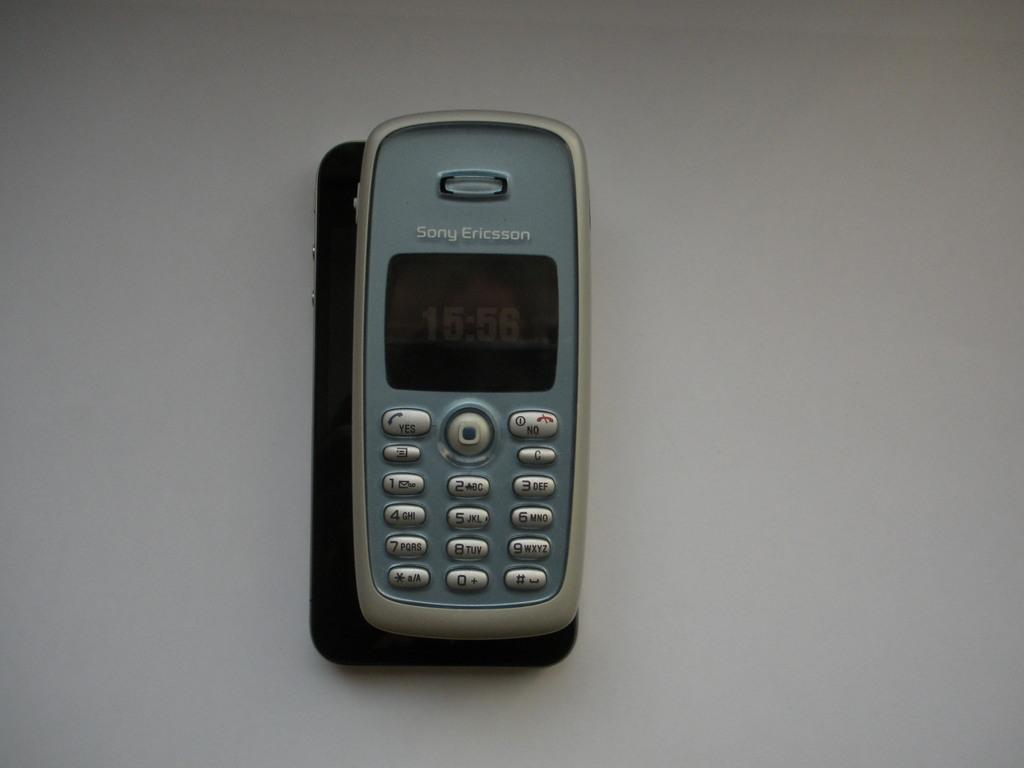<image>
Present a compact description of the photo's key features. Old cellphone with the name Sony Ericsson on the top. 